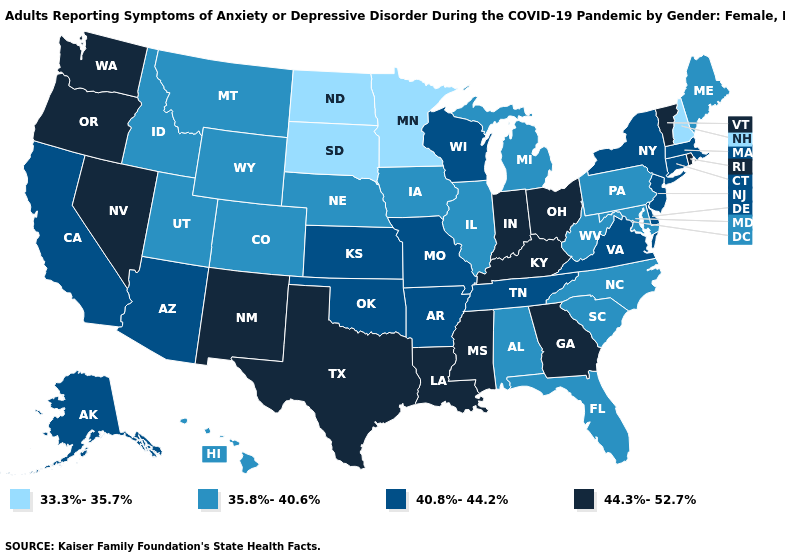What is the value of Michigan?
Quick response, please. 35.8%-40.6%. Which states have the lowest value in the Northeast?
Answer briefly. New Hampshire. How many symbols are there in the legend?
Short answer required. 4. What is the lowest value in the USA?
Be succinct. 33.3%-35.7%. Which states have the lowest value in the USA?
Write a very short answer. Minnesota, New Hampshire, North Dakota, South Dakota. Among the states that border Louisiana , which have the highest value?
Write a very short answer. Mississippi, Texas. What is the highest value in the South ?
Give a very brief answer. 44.3%-52.7%. What is the highest value in states that border Kentucky?
Quick response, please. 44.3%-52.7%. Name the states that have a value in the range 35.8%-40.6%?
Be succinct. Alabama, Colorado, Florida, Hawaii, Idaho, Illinois, Iowa, Maine, Maryland, Michigan, Montana, Nebraska, North Carolina, Pennsylvania, South Carolina, Utah, West Virginia, Wyoming. Name the states that have a value in the range 40.8%-44.2%?
Be succinct. Alaska, Arizona, Arkansas, California, Connecticut, Delaware, Kansas, Massachusetts, Missouri, New Jersey, New York, Oklahoma, Tennessee, Virginia, Wisconsin. What is the highest value in the USA?
Short answer required. 44.3%-52.7%. Name the states that have a value in the range 35.8%-40.6%?
Write a very short answer. Alabama, Colorado, Florida, Hawaii, Idaho, Illinois, Iowa, Maine, Maryland, Michigan, Montana, Nebraska, North Carolina, Pennsylvania, South Carolina, Utah, West Virginia, Wyoming. What is the value of Connecticut?
Write a very short answer. 40.8%-44.2%. What is the value of Georgia?
Concise answer only. 44.3%-52.7%. Does Wisconsin have the same value as New Jersey?
Quick response, please. Yes. 